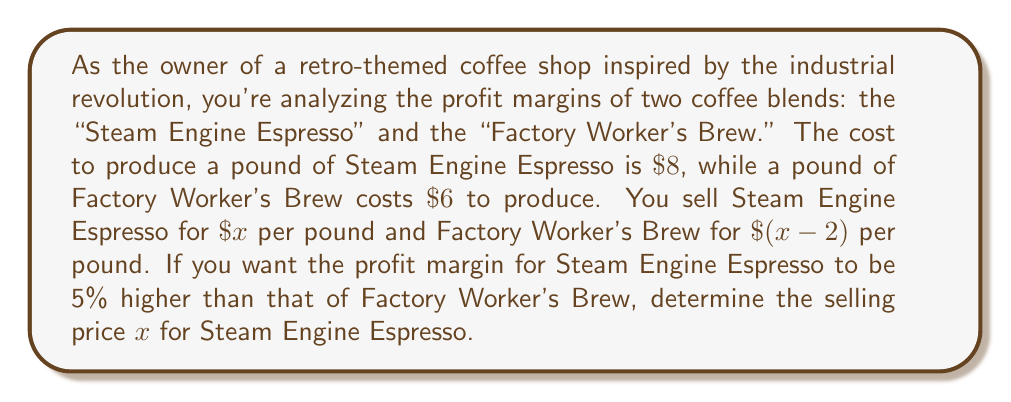Solve this math problem. Let's approach this step-by-step:

1) First, let's define profit margin:
   Profit Margin = $\frac{\text{Selling Price - Cost}}{\text{Selling Price}} \times 100\%$

2) For Steam Engine Espresso:
   Profit Margin = $\frac{x - 8}{x} \times 100\%$

3) For Factory Worker's Brew:
   Profit Margin = $\frac{(x-2) - 6}{x-2} \times 100\% = \frac{x - 8}{x-2} \times 100\%$

4) We want the profit margin of Steam Engine Espresso to be 5% higher than Factory Worker's Brew. Let's set up an equation:

   $\frac{x - 8}{x} = \frac{x - 8}{x-2} + 0.05$

5) Cross-multiply:
   $(x - 8)(x-2) = x(x - 8) + 0.05x(x-2)$

6) Expand:
   $x^2 - 10x + 16 = x^2 - 8x + 0.05x^2 - 0.1x$

7) Simplify:
   $0.95x^2 - 1.9x + 16 = 0$

8) Multiply all terms by 20 to eliminate decimals:
   $19x^2 - 38x + 320 = 0$

9) This is a quadratic equation. We can solve it using the quadratic formula:
   $x = \frac{-b \pm \sqrt{b^2 - 4ac}}{2a}$

   Where $a = 19$, $b = -38$, and $c = 320$

10) Plugging in these values:
    $x = \frac{38 \pm \sqrt{(-38)^2 - 4(19)(320)}}{2(19)}$

11) Simplify:
    $x = \frac{38 \pm \sqrt{1444 - 24320}}{38} = \frac{38 \pm \sqrt{-22876}}{38}$

12) Since we can't have a negative value under the square root for a real solution, and we need a positive price, the only valid solution is:

    $x = \frac{38}{38} = 1$

Therefore, the selling price for Steam Engine Espresso should be $\$10$ per pound.
Answer: $\$10$ per pound 